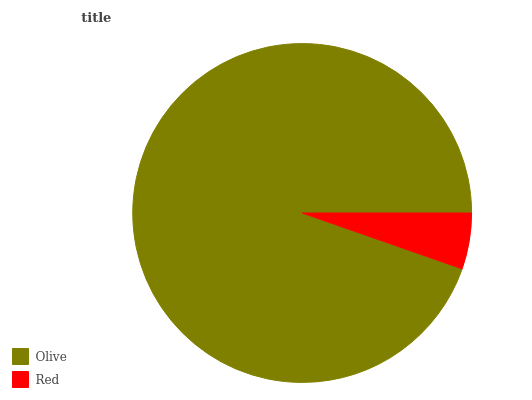Is Red the minimum?
Answer yes or no. Yes. Is Olive the maximum?
Answer yes or no. Yes. Is Red the maximum?
Answer yes or no. No. Is Olive greater than Red?
Answer yes or no. Yes. Is Red less than Olive?
Answer yes or no. Yes. Is Red greater than Olive?
Answer yes or no. No. Is Olive less than Red?
Answer yes or no. No. Is Olive the high median?
Answer yes or no. Yes. Is Red the low median?
Answer yes or no. Yes. Is Red the high median?
Answer yes or no. No. Is Olive the low median?
Answer yes or no. No. 